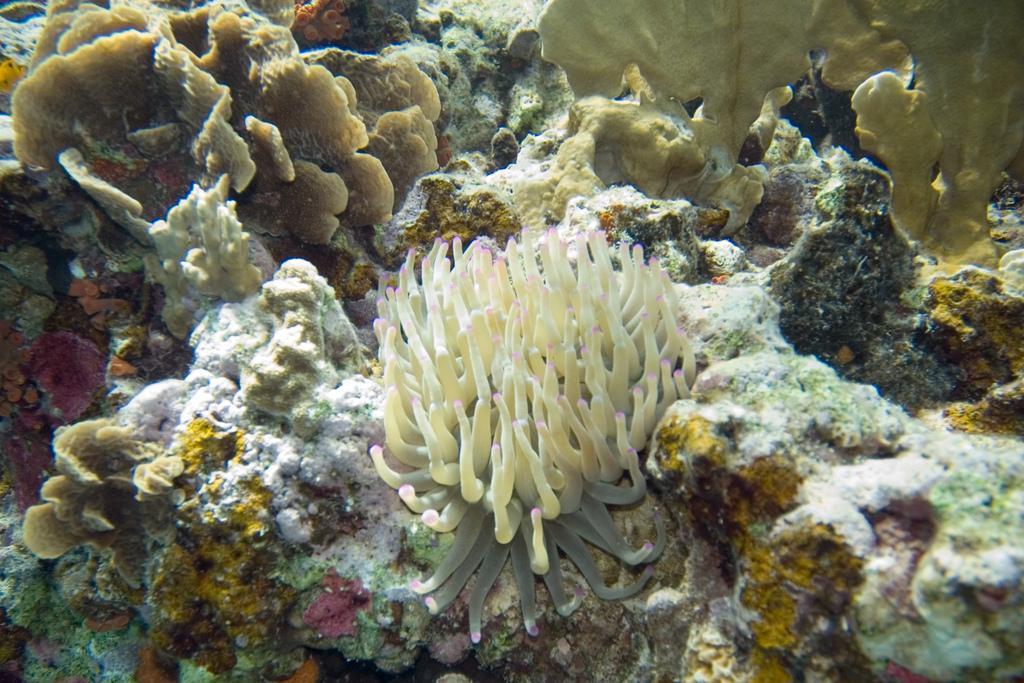How would you summarize this image in a sentence or two? In this image I can see the under water picture in which I can see few aquatic plants and rocks. 